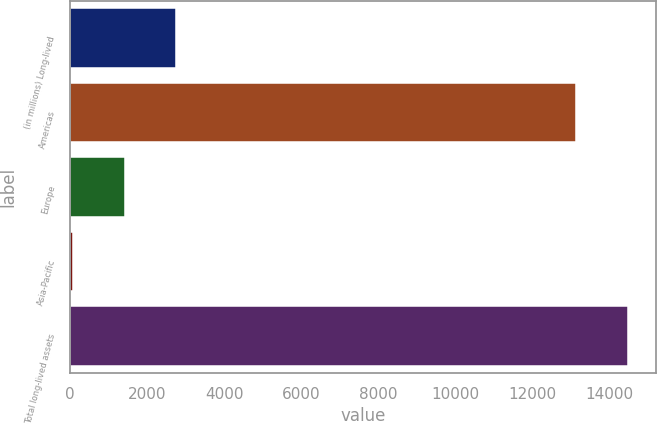Convert chart to OTSL. <chart><loc_0><loc_0><loc_500><loc_500><bar_chart><fcel>(in millions) Long-lived<fcel>Americas<fcel>Europe<fcel>Asia-Pacific<fcel>Total long-lived assets<nl><fcel>2752<fcel>13151<fcel>1417.5<fcel>83<fcel>14485.5<nl></chart> 